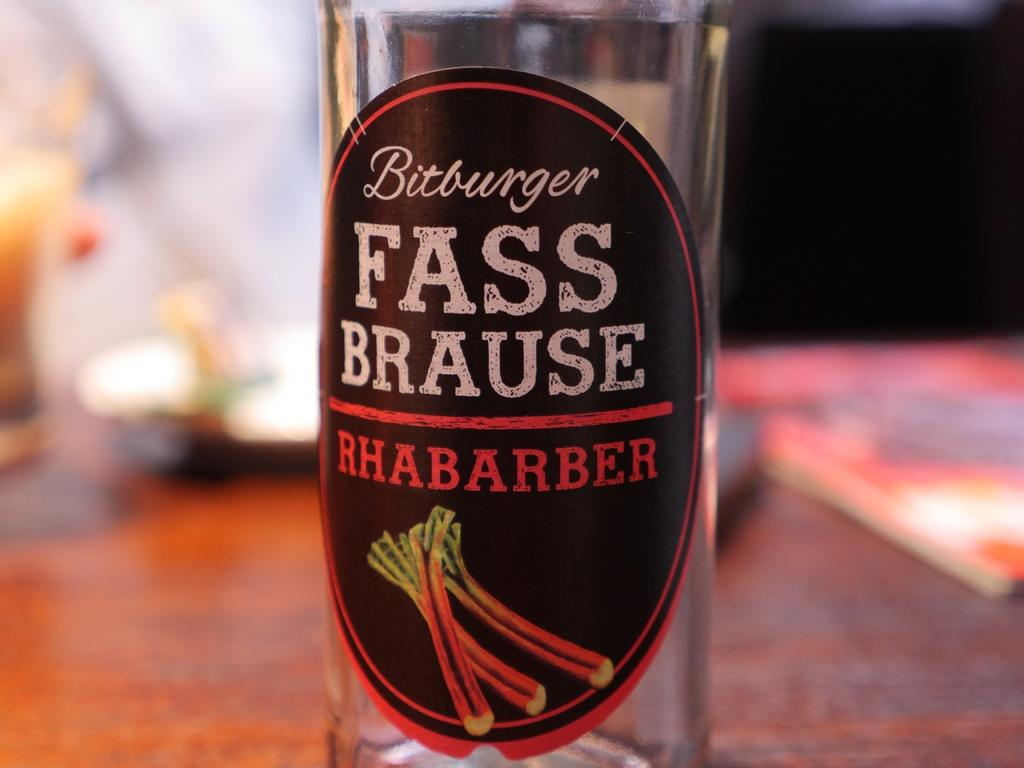What piece of furniture is present in the image? There is a table in the image. What items are placed on the table? There is a bottle, a plate, and a wine glass on the table. What type of pancake is being served on the plate in the image? There is no pancake present in the image; the plate is empty. 